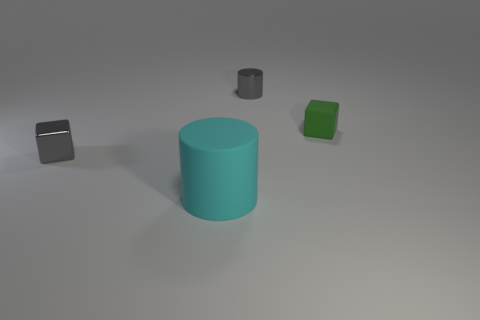Subtract all cyan cylinders. How many cylinders are left? 1 Subtract all cyan cylinders. Subtract all green cubes. How many cylinders are left? 1 Subtract all blue cubes. How many blue cylinders are left? 0 Subtract all big objects. Subtract all small cylinders. How many objects are left? 2 Add 3 gray shiny blocks. How many gray shiny blocks are left? 4 Add 1 blue blocks. How many blue blocks exist? 1 Add 4 small gray blocks. How many objects exist? 8 Subtract 0 green cylinders. How many objects are left? 4 Subtract 1 cubes. How many cubes are left? 1 